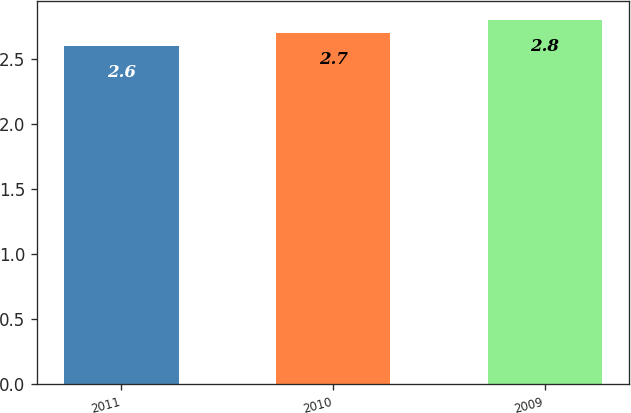<chart> <loc_0><loc_0><loc_500><loc_500><bar_chart><fcel>2011<fcel>2010<fcel>2009<nl><fcel>2.6<fcel>2.7<fcel>2.8<nl></chart> 